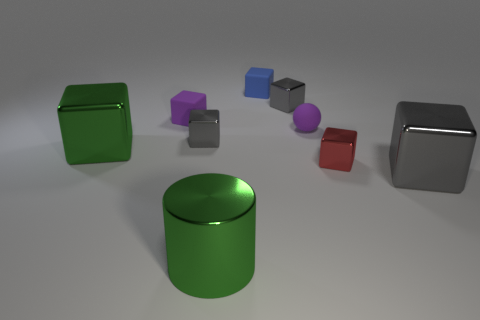There is a small object that is in front of the purple rubber ball and behind the red thing; what color is it?
Provide a succinct answer. Gray. There is a purple thing that is the same shape as the red metal object; what size is it?
Your response must be concise. Small. What number of purple matte objects have the same size as the red thing?
Provide a succinct answer. 2. What is the small sphere made of?
Offer a terse response. Rubber. Are there any large cylinders to the right of the big gray shiny thing?
Make the answer very short. No. What is the size of the cylinder that is made of the same material as the red block?
Make the answer very short. Large. How many small cubes are the same color as the small sphere?
Give a very brief answer. 1. Are there fewer things that are right of the big green cylinder than green metal cubes that are behind the small blue object?
Your response must be concise. No. What size is the gray metallic block in front of the small red block?
Your answer should be compact. Large. What is the size of the rubber object that is the same color as the tiny ball?
Your answer should be very brief. Small. 